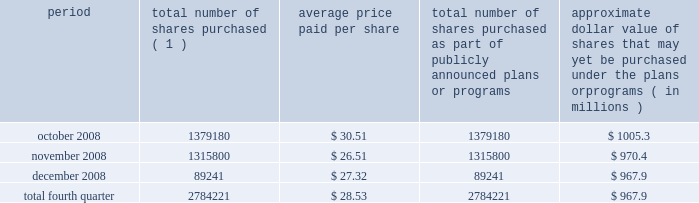Act of 1933 , as amended , and section 1145 of the united states code .
No underwriters were engaged in connection with such issuances .
During the three months ended december 31 , 2008 , we issued an aggregate of 7173456 shares of our common stock upon conversion of $ 147.1 million principal amount of our 3.00% ( 3.00 % ) notes .
Pursuant to the terms of the indenture , holders of the 3.00% ( 3.00 % ) notes receive 48.7805 shares of our common stock for every $ 1000 principal amount of notes converted .
In connection with the conversions , we paid such holders an aggregate of approximately $ 3.7 million , calculated based on the accrued and unpaid interest on the notes and the discounted value of the future interest payments on the notes .
All shares were issued in reliance on the exemption from registration set forth in section 3 ( a ) ( 9 ) of the securities act of 1933 , as amended .
No underwriters were engaged in connection with such issuances .
Issuer purchases of equity securities during the three months ended december 31 , 2008 , we repurchased 2784221 shares of our common stock for an aggregate of $ 79.4 million , including commissions and fees , pursuant to our publicly announced stock repurchase program , as follows : period total number of shares purchased ( 1 ) average price paid per share total number of shares purchased as part of publicly announced plans or programs approximate dollar value of shares that may yet be purchased under the plans or programs ( in millions ) .
( 1 ) repurchases made pursuant to the $ 1.5 billion stock repurchase program approved by our board of directors in february 2008 .
Under this program , our management is authorized to purchase shares from time to time through open market purchases or privately negotiated transactions at prevailing prices as permitted by securities laws and other legal requirements , and subject to market conditions and other factors .
To facilitate repurchases , we make purchases pursuant to a trading plan under rule 10b5-1 of the exchange act , which allows us to repurchase shares during periods when we otherwise might be prevented from doing so under insider trading laws or because of self-imposed trading blackout periods .
This program may be discontinued at any time .
As reflected in the above table , in the fourth quarter of 2008 , we significantly reduced purchases of common stock under our stock repurchase program based on the downturn in the economy and the disruptions in the financial and credit markets .
Subsequent to december 31 , 2008 , we repurchased approximately 28000 shares of our common stock for an aggregate of $ 0.8 million , including commissions and fees , pursuant to this program .
We expect to continue to manage the pacing of the program in the future in response to general market conditions and other relevant factors. .
In the fourth quarter of 2008 what was the percent of the shares bought in october? 
Computations: (1379180 / 2784221)
Answer: 0.49536. 